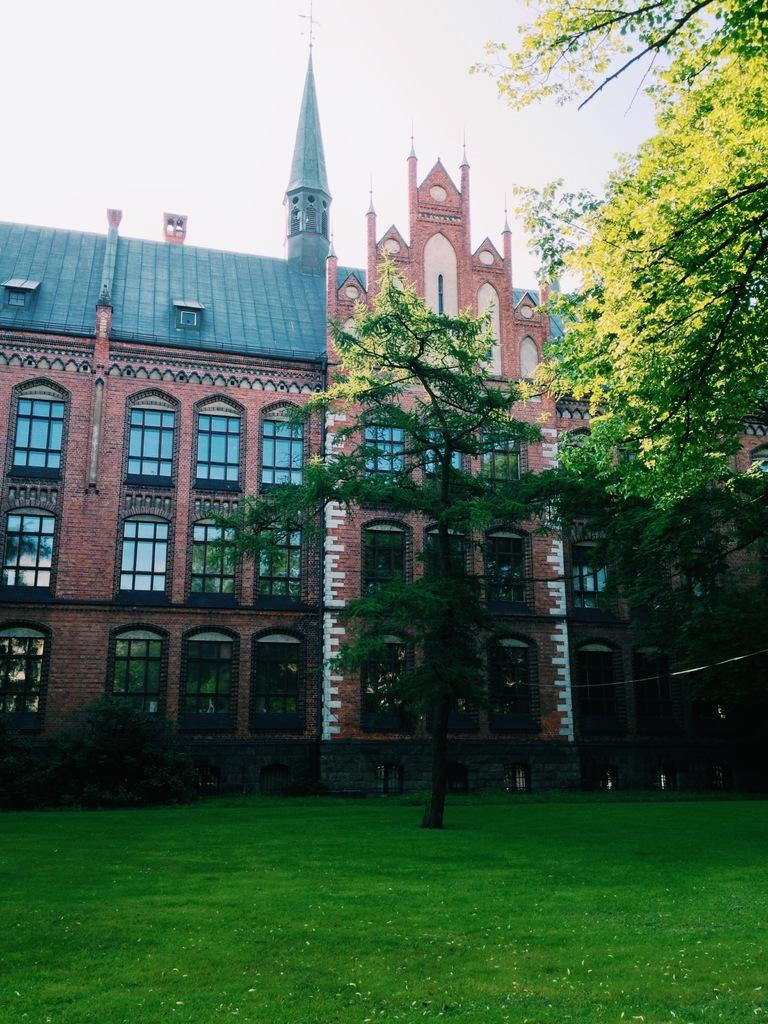What type of vegetation is present in the image? There is grass and trees in the image. What can be seen in the background of the image? There is a building, windows, and the sky visible in the background of the image. What type of fruit can be seen growing on the trees in the image? There is no fruit visible on the trees in the image; only grass, trees, and the background elements are present. 